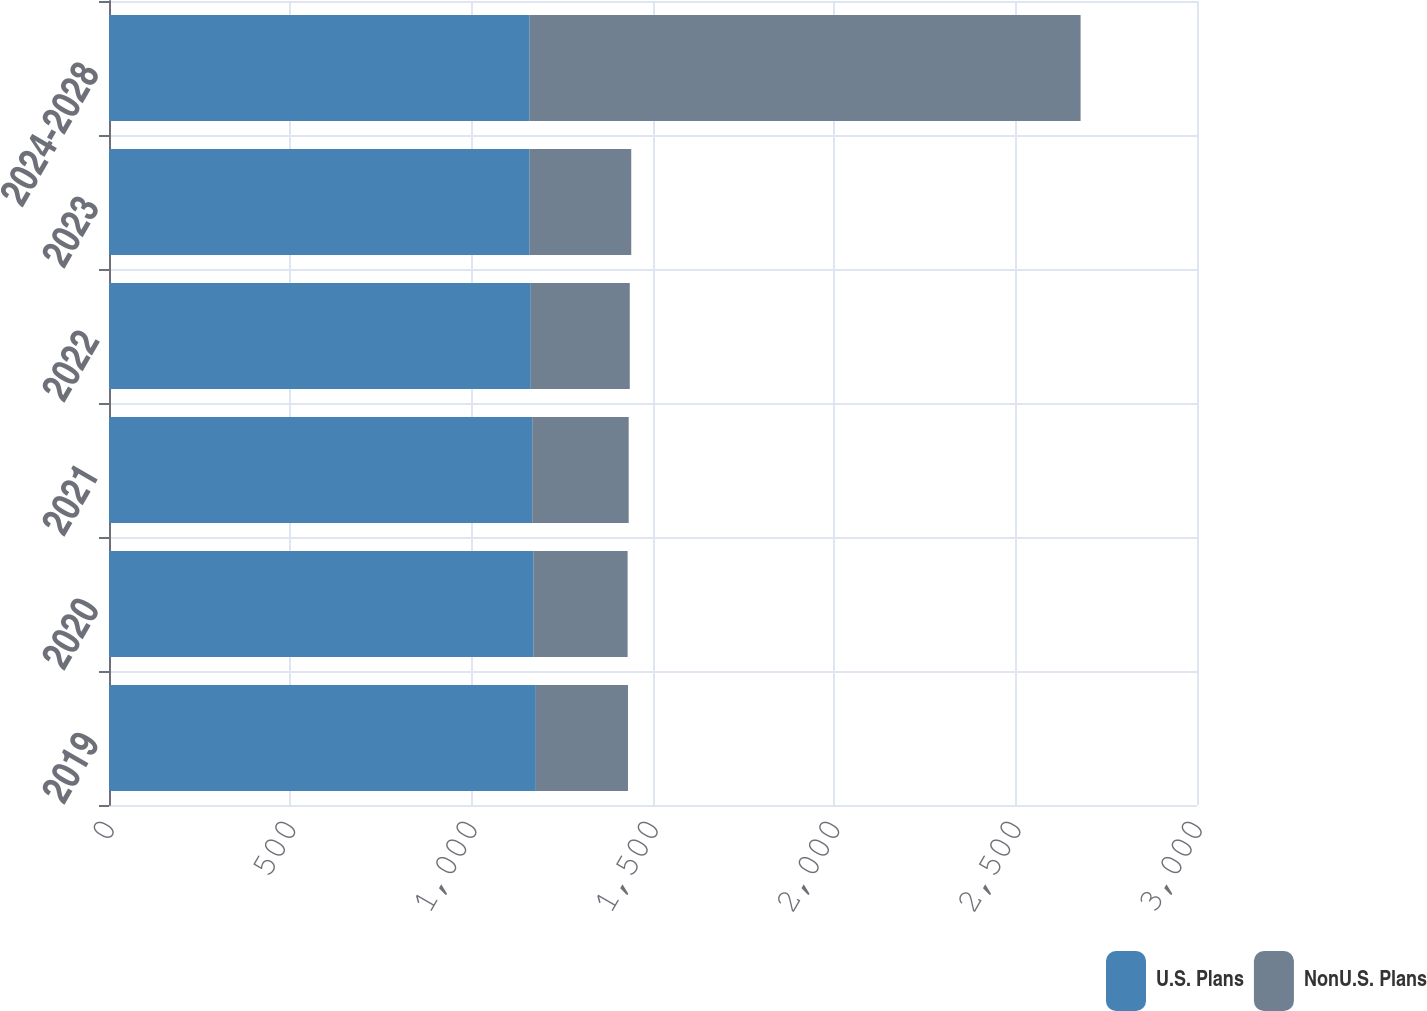Convert chart to OTSL. <chart><loc_0><loc_0><loc_500><loc_500><stacked_bar_chart><ecel><fcel>2019<fcel>2020<fcel>2021<fcel>2022<fcel>2023<fcel>2024-2028<nl><fcel>U.S. Plans<fcel>1177<fcel>1171<fcel>1167<fcel>1163<fcel>1160<fcel>1160<nl><fcel>NonU.S. Plans<fcel>254<fcel>259<fcel>266<fcel>273<fcel>280<fcel>1519<nl></chart> 